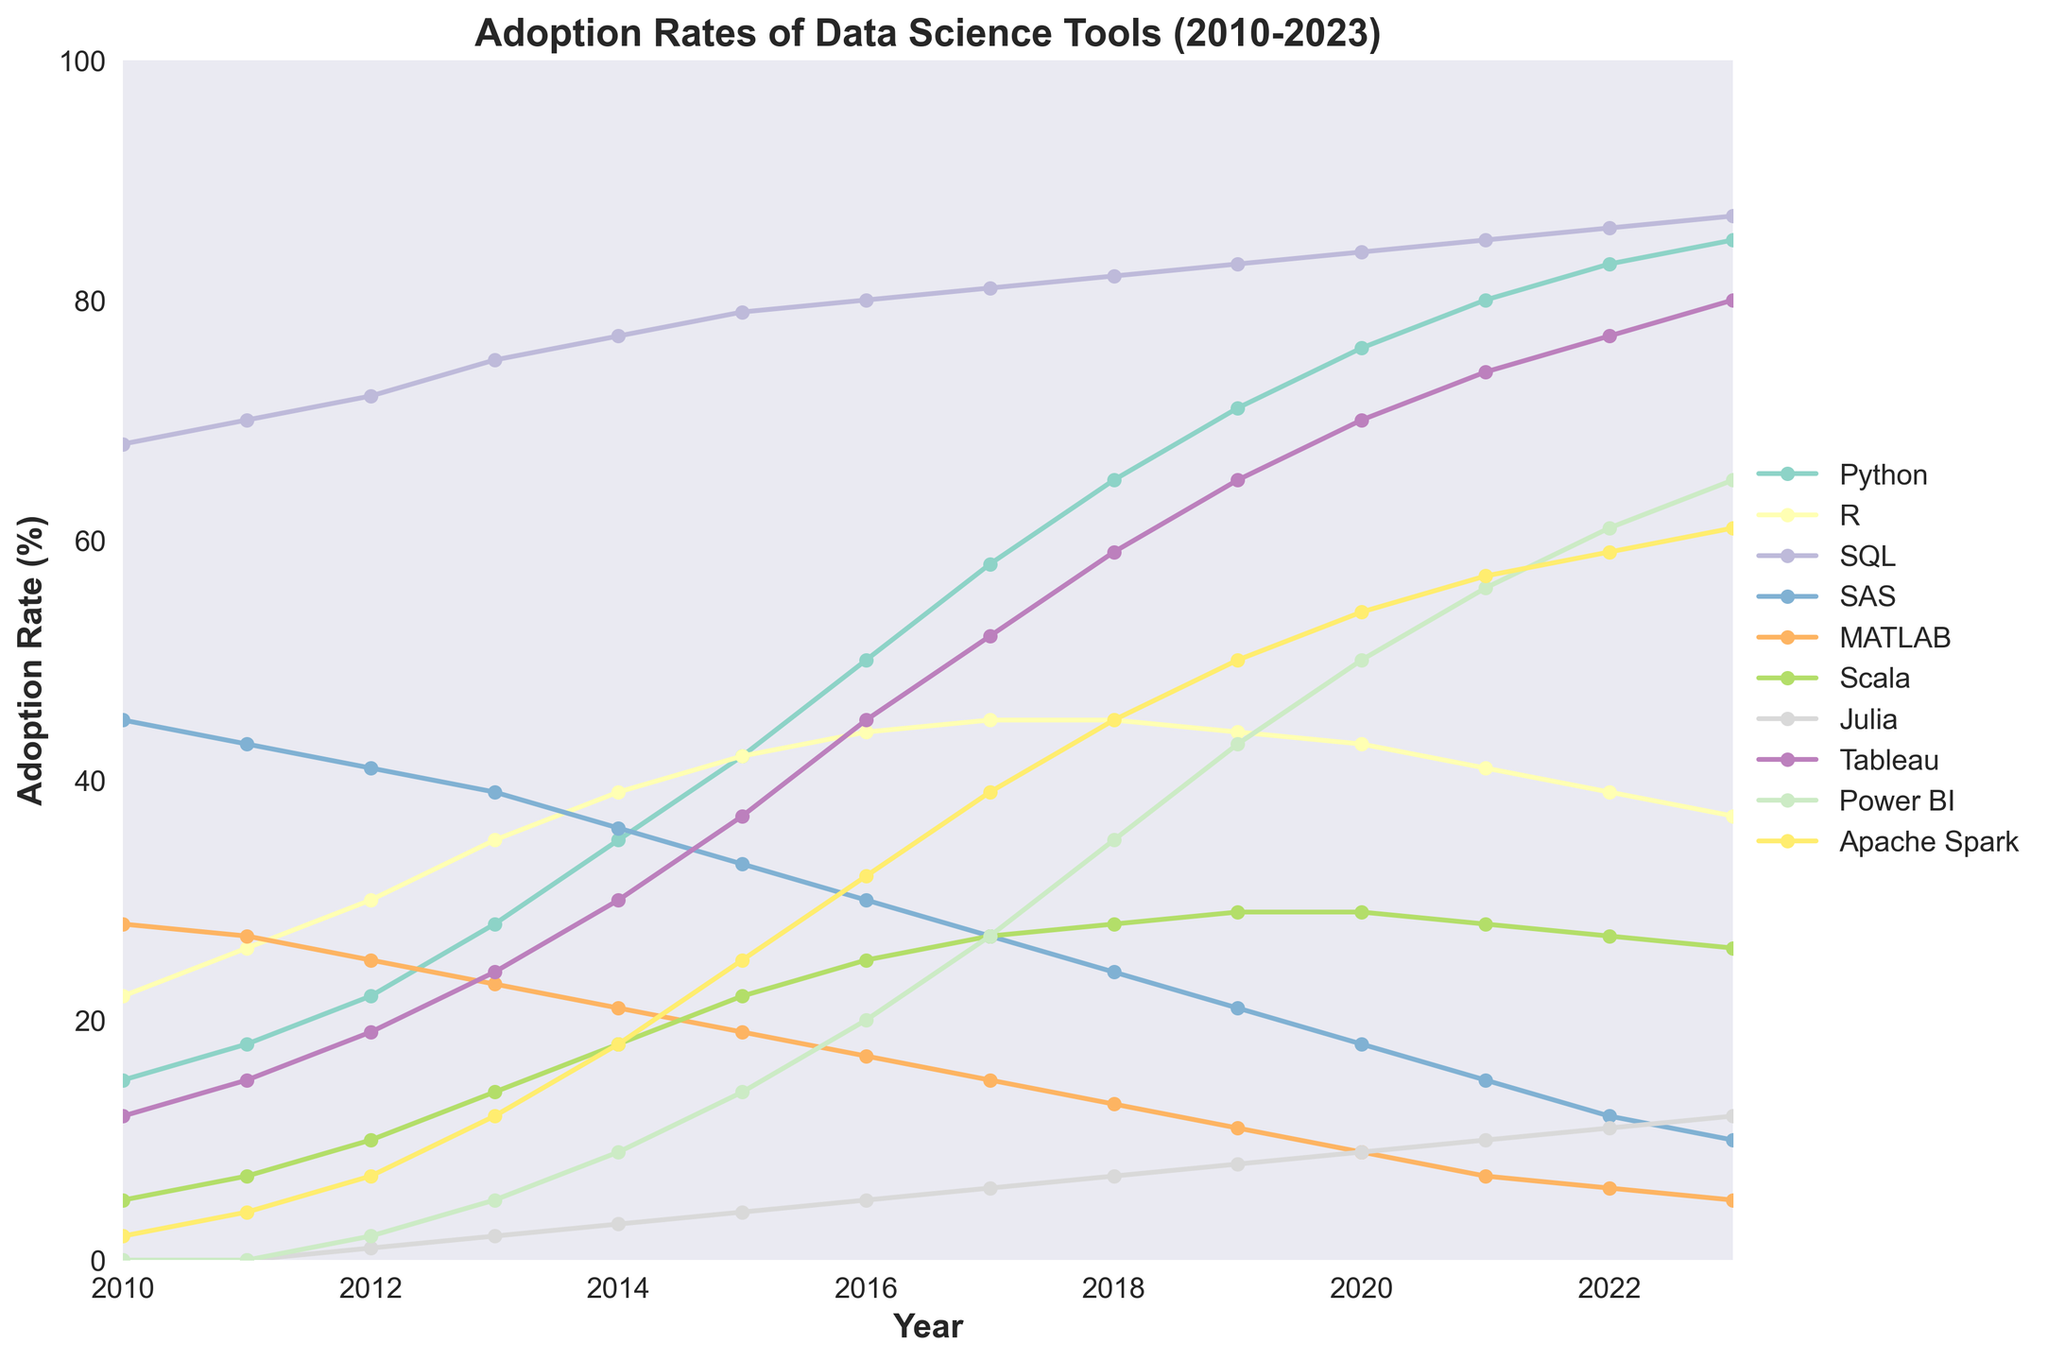Which tool showed the most significant increase in adoption rates from 2010 to 2023? To find the tool with the most significant increase, we need to calculate the difference in adoption rates for each tool between 2023 and 2010. Comparing these differences, Python increased from 15% to 85%, a rise of 70%. No other tool showed a greater increase.
Answer: Python Which year did Python surpass SAS in adoption rates? To determine the year Python surpassed SAS, we look for the first year where Python's adoption rate exceeded SAS's. Python's adoption rate of 28% in 2013 surpassed SAS's adoption rate of 27%.
Answer: 2013 In 2023, which tool has the lowest adoption rate? To find the tool with the lowest adoption rate in 2023, we compare the values for all the tools in 2023. Julia has the lowest adoption rate at 12%.
Answer: Julia What is the average adoption rate of SQL from 2010 to 2023? To find the average adoption rate of SQL from 2010 to 2023, we sum the adoption rates for each year (68+70+72+75+77+79+80+81+82+83+84+85+86+87 = 1119) and divide by the number of years (2023-2010+1 = 14). The calculation is 1119/14 = 79.93%.
Answer: 79.93% Compare the adoption rates of Tableau and Power BI in 2020. Which one is higher and by how much? In 2020, Tableau's adoption rate is 70% and Power BI's is 50%. To find the difference, subtract Power BI's rate from Tableau's (70 - 50 = 20). Tableau's adoption rate is 20% higher.
Answer: Tableau by 20% How did the adoption rate of R change from 2016 to 2023? To find the change in adoption rate of R, subtract its rate in 2023 from the rate in 2016 (37 - 44 = -7). The adoption rate of R decreased by 7% from 2016 to 2023.
Answer: Decreased by 7% Which tool had a steady adoption rate from 2017 to 2023? By examining the line trends from 2017 to 2023, SQL (around 81-87%) and Julia (around 6-12%) show relatively minor fluctuations. SQL is the steadiest.
Answer: SQL Which tool had the steepest drop in adoption rates between any two consecutive years? Analyzing all consecutive year differences, SAS from 2013 to 2014 dropped from 39% to 36%, which is the largest single-year drop of 3%.
Answer: SAS From 2015 to 2016, which tool had the highest growth in adoption rate? To find the tool with the highest growth between 2015 and 2016, calculate the difference for each tool. Python increased from 42% to 50%, the highest growth of 8%.
Answer: Python 